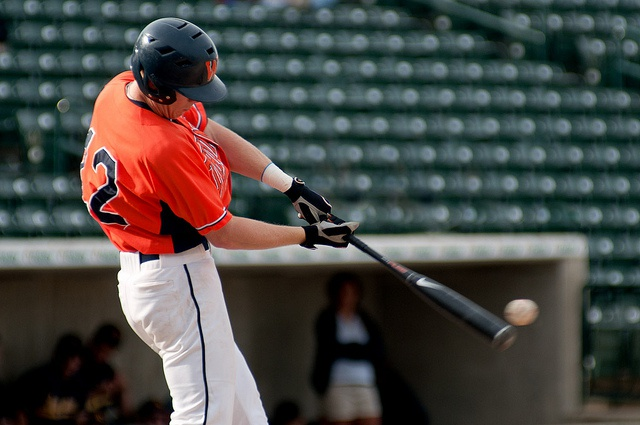Describe the objects in this image and their specific colors. I can see people in black, lightgray, darkgray, and brown tones, people in black and gray tones, people in black and maroon tones, baseball bat in black, gray, and darkblue tones, and people in black tones in this image. 